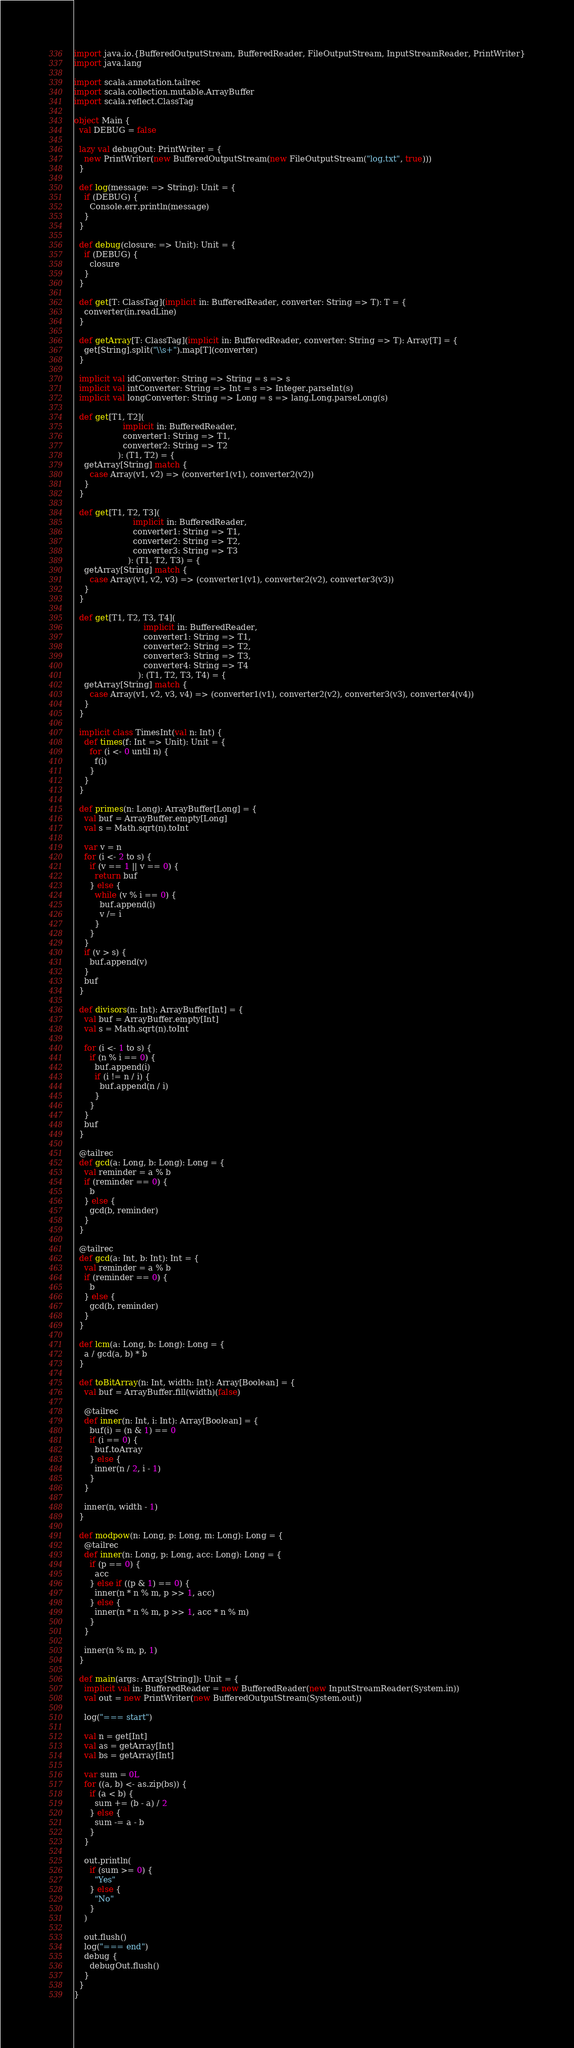<code> <loc_0><loc_0><loc_500><loc_500><_Scala_>import java.io.{BufferedOutputStream, BufferedReader, FileOutputStream, InputStreamReader, PrintWriter}
import java.lang

import scala.annotation.tailrec
import scala.collection.mutable.ArrayBuffer
import scala.reflect.ClassTag

object Main {
  val DEBUG = false

  lazy val debugOut: PrintWriter = {
    new PrintWriter(new BufferedOutputStream(new FileOutputStream("log.txt", true)))
  }

  def log(message: => String): Unit = {
    if (DEBUG) {
      Console.err.println(message)
    }
  }

  def debug(closure: => Unit): Unit = {
    if (DEBUG) {
      closure
    }
  }

  def get[T: ClassTag](implicit in: BufferedReader, converter: String => T): T = {
    converter(in.readLine)
  }

  def getArray[T: ClassTag](implicit in: BufferedReader, converter: String => T): Array[T] = {
    get[String].split("\\s+").map[T](converter)
  }

  implicit val idConverter: String => String = s => s
  implicit val intConverter: String => Int = s => Integer.parseInt(s)
  implicit val longConverter: String => Long = s => lang.Long.parseLong(s)

  def get[T1, T2](
                   implicit in: BufferedReader,
                   converter1: String => T1,
                   converter2: String => T2
                 ): (T1, T2) = {
    getArray[String] match {
      case Array(v1, v2) => (converter1(v1), converter2(v2))
    }
  }

  def get[T1, T2, T3](
                       implicit in: BufferedReader,
                       converter1: String => T1,
                       converter2: String => T2,
                       converter3: String => T3
                     ): (T1, T2, T3) = {
    getArray[String] match {
      case Array(v1, v2, v3) => (converter1(v1), converter2(v2), converter3(v3))
    }
  }

  def get[T1, T2, T3, T4](
                           implicit in: BufferedReader,
                           converter1: String => T1,
                           converter2: String => T2,
                           converter3: String => T3,
                           converter4: String => T4
                         ): (T1, T2, T3, T4) = {
    getArray[String] match {
      case Array(v1, v2, v3, v4) => (converter1(v1), converter2(v2), converter3(v3), converter4(v4))
    }
  }

  implicit class TimesInt(val n: Int) {
    def times(f: Int => Unit): Unit = {
      for (i <- 0 until n) {
        f(i)
      }
    }
  }

  def primes(n: Long): ArrayBuffer[Long] = {
    val buf = ArrayBuffer.empty[Long]
    val s = Math.sqrt(n).toInt

    var v = n
    for (i <- 2 to s) {
      if (v == 1 || v == 0) {
        return buf
      } else {
        while (v % i == 0) {
          buf.append(i)
          v /= i
        }
      }
    }
    if (v > s) {
      buf.append(v)
    }
    buf
  }

  def divisors(n: Int): ArrayBuffer[Int] = {
    val buf = ArrayBuffer.empty[Int]
    val s = Math.sqrt(n).toInt

    for (i <- 1 to s) {
      if (n % i == 0) {
        buf.append(i)
        if (i != n / i) {
          buf.append(n / i)
        }
      }
    }
    buf
  }

  @tailrec
  def gcd(a: Long, b: Long): Long = {
    val reminder = a % b
    if (reminder == 0) {
      b
    } else {
      gcd(b, reminder)
    }
  }

  @tailrec
  def gcd(a: Int, b: Int): Int = {
    val reminder = a % b
    if (reminder == 0) {
      b
    } else {
      gcd(b, reminder)
    }
  }

  def lcm(a: Long, b: Long): Long = {
    a / gcd(a, b) * b
  }

  def toBitArray(n: Int, width: Int): Array[Boolean] = {
    val buf = ArrayBuffer.fill(width)(false)

    @tailrec
    def inner(n: Int, i: Int): Array[Boolean] = {
      buf(i) = (n & 1) == 0
      if (i == 0) {
        buf.toArray
      } else {
        inner(n / 2, i - 1)
      }
    }

    inner(n, width - 1)
  }

  def modpow(n: Long, p: Long, m: Long): Long = {
    @tailrec
    def inner(n: Long, p: Long, acc: Long): Long = {
      if (p == 0) {
        acc
      } else if ((p & 1) == 0) {
        inner(n * n % m, p >> 1, acc)
      } else {
        inner(n * n % m, p >> 1, acc * n % m)
      }
    }

    inner(n % m, p, 1)
  }

  def main(args: Array[String]): Unit = {
    implicit val in: BufferedReader = new BufferedReader(new InputStreamReader(System.in))
    val out = new PrintWriter(new BufferedOutputStream(System.out))

    log("=== start")

    val n = get[Int]
    val as = getArray[Int]
    val bs = getArray[Int]

    var sum = 0L
    for ((a, b) <- as.zip(bs)) {
      if (a < b) {
        sum += (b - a) / 2
      } else {
        sum -= a - b
      }
    }

    out.println(
      if (sum >= 0) {
        "Yes"
      } else {
        "No"
      }
    )

    out.flush()
    log("=== end")
    debug {
      debugOut.flush()
    }
  }
}</code> 